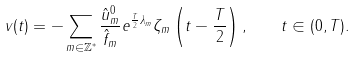<formula> <loc_0><loc_0><loc_500><loc_500>v ( t ) = - \sum _ { m \in \mathbb { Z } ^ { * } } \frac { \hat { u } _ { m } ^ { 0 } } { \hat { f } _ { m } } e ^ { \frac { T } { 2 } \lambda _ { m } } \zeta _ { m } \left ( t - \frac { T } { 2 } \right ) , \quad t \in ( 0 , T ) .</formula> 